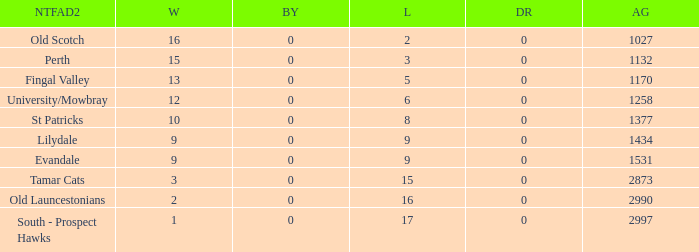What is the lowest number of draws of the team with 9 wins and less than 0 byes? None. 